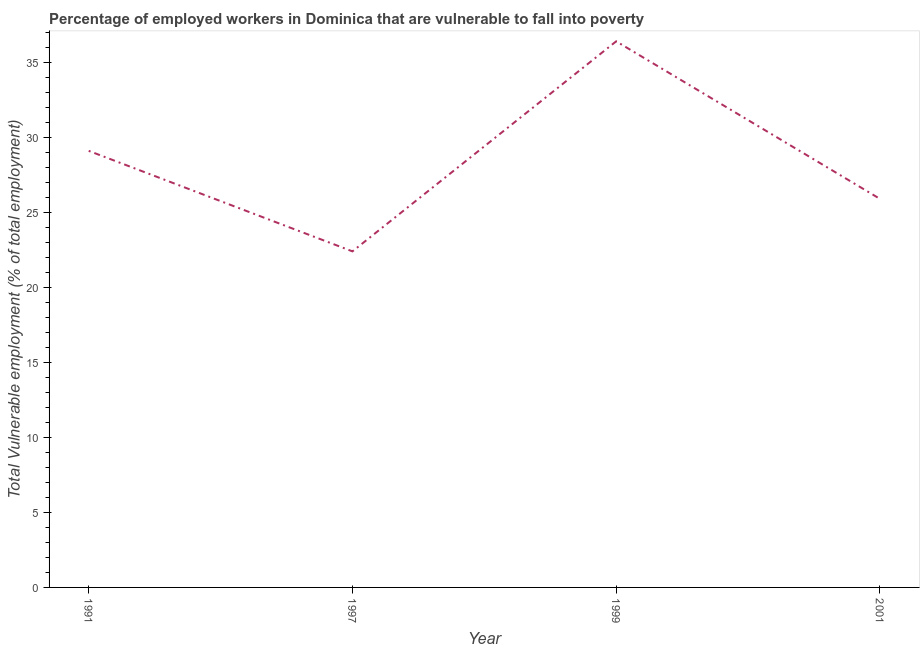What is the total vulnerable employment in 2001?
Keep it short and to the point. 25.9. Across all years, what is the maximum total vulnerable employment?
Provide a succinct answer. 36.4. Across all years, what is the minimum total vulnerable employment?
Offer a very short reply. 22.4. In which year was the total vulnerable employment minimum?
Keep it short and to the point. 1997. What is the sum of the total vulnerable employment?
Provide a short and direct response. 113.8. What is the difference between the total vulnerable employment in 1997 and 2001?
Provide a short and direct response. -3.5. What is the average total vulnerable employment per year?
Your answer should be very brief. 28.45. What is the ratio of the total vulnerable employment in 1997 to that in 2001?
Provide a succinct answer. 0.86. Is the total vulnerable employment in 1991 less than that in 1999?
Make the answer very short. Yes. What is the difference between the highest and the second highest total vulnerable employment?
Provide a succinct answer. 7.3. Is the sum of the total vulnerable employment in 1997 and 1999 greater than the maximum total vulnerable employment across all years?
Your response must be concise. Yes. What is the difference between the highest and the lowest total vulnerable employment?
Give a very brief answer. 14. Does the total vulnerable employment monotonically increase over the years?
Make the answer very short. No. How many lines are there?
Your response must be concise. 1. What is the difference between two consecutive major ticks on the Y-axis?
Make the answer very short. 5. Are the values on the major ticks of Y-axis written in scientific E-notation?
Provide a short and direct response. No. What is the title of the graph?
Offer a very short reply. Percentage of employed workers in Dominica that are vulnerable to fall into poverty. What is the label or title of the Y-axis?
Provide a short and direct response. Total Vulnerable employment (% of total employment). What is the Total Vulnerable employment (% of total employment) in 1991?
Your answer should be compact. 29.1. What is the Total Vulnerable employment (% of total employment) in 1997?
Ensure brevity in your answer.  22.4. What is the Total Vulnerable employment (% of total employment) in 1999?
Your response must be concise. 36.4. What is the Total Vulnerable employment (% of total employment) of 2001?
Keep it short and to the point. 25.9. What is the difference between the Total Vulnerable employment (% of total employment) in 1991 and 2001?
Your response must be concise. 3.2. What is the difference between the Total Vulnerable employment (% of total employment) in 1997 and 1999?
Keep it short and to the point. -14. What is the difference between the Total Vulnerable employment (% of total employment) in 1999 and 2001?
Offer a terse response. 10.5. What is the ratio of the Total Vulnerable employment (% of total employment) in 1991 to that in 1997?
Provide a short and direct response. 1.3. What is the ratio of the Total Vulnerable employment (% of total employment) in 1991 to that in 1999?
Your response must be concise. 0.8. What is the ratio of the Total Vulnerable employment (% of total employment) in 1991 to that in 2001?
Your answer should be compact. 1.12. What is the ratio of the Total Vulnerable employment (% of total employment) in 1997 to that in 1999?
Your response must be concise. 0.61. What is the ratio of the Total Vulnerable employment (% of total employment) in 1997 to that in 2001?
Provide a succinct answer. 0.86. What is the ratio of the Total Vulnerable employment (% of total employment) in 1999 to that in 2001?
Keep it short and to the point. 1.41. 